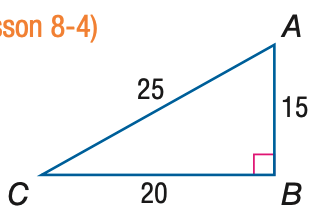Answer the mathemtical geometry problem and directly provide the correct option letter.
Question: Express the ratio of \sin A as a decimal to the nearest hundredth.
Choices: A: 0.60 B: 0.75 C: 0.80 D: 1.33 C 